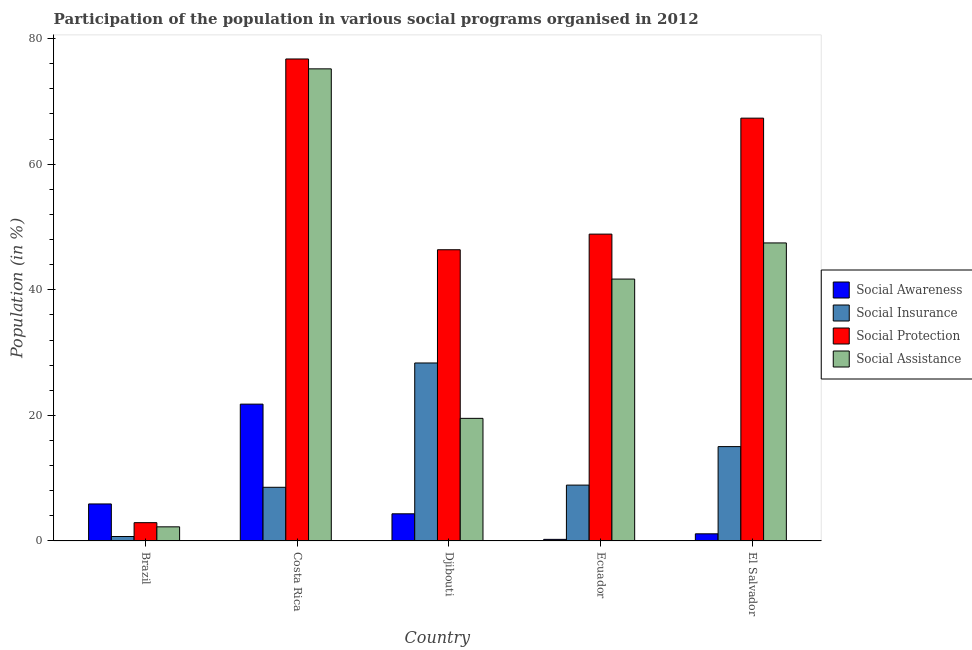Are the number of bars per tick equal to the number of legend labels?
Your answer should be compact. Yes. How many bars are there on the 4th tick from the left?
Give a very brief answer. 4. In how many cases, is the number of bars for a given country not equal to the number of legend labels?
Give a very brief answer. 0. What is the participation of population in social protection programs in Brazil?
Your answer should be very brief. 2.92. Across all countries, what is the maximum participation of population in social awareness programs?
Provide a succinct answer. 21.79. Across all countries, what is the minimum participation of population in social assistance programs?
Your answer should be compact. 2.25. In which country was the participation of population in social awareness programs minimum?
Provide a short and direct response. Ecuador. What is the total participation of population in social awareness programs in the graph?
Provide a short and direct response. 33.41. What is the difference between the participation of population in social assistance programs in Costa Rica and that in Djibouti?
Your response must be concise. 55.65. What is the difference between the participation of population in social assistance programs in Ecuador and the participation of population in social insurance programs in Brazil?
Give a very brief answer. 40.99. What is the average participation of population in social protection programs per country?
Keep it short and to the point. 48.45. What is the difference between the participation of population in social protection programs and participation of population in social insurance programs in Brazil?
Give a very brief answer. 2.2. In how many countries, is the participation of population in social awareness programs greater than 48 %?
Your answer should be compact. 0. What is the ratio of the participation of population in social assistance programs in Djibouti to that in El Salvador?
Ensure brevity in your answer.  0.41. Is the participation of population in social protection programs in Brazil less than that in El Salvador?
Keep it short and to the point. Yes. What is the difference between the highest and the second highest participation of population in social awareness programs?
Your answer should be very brief. 15.89. What is the difference between the highest and the lowest participation of population in social assistance programs?
Give a very brief answer. 72.93. Is the sum of the participation of population in social assistance programs in Djibouti and Ecuador greater than the maximum participation of population in social protection programs across all countries?
Ensure brevity in your answer.  No. Is it the case that in every country, the sum of the participation of population in social protection programs and participation of population in social assistance programs is greater than the sum of participation of population in social insurance programs and participation of population in social awareness programs?
Your answer should be compact. No. What does the 1st bar from the left in Costa Rica represents?
Keep it short and to the point. Social Awareness. What does the 2nd bar from the right in El Salvador represents?
Ensure brevity in your answer.  Social Protection. Is it the case that in every country, the sum of the participation of population in social awareness programs and participation of population in social insurance programs is greater than the participation of population in social protection programs?
Provide a succinct answer. No. How many bars are there?
Your answer should be compact. 20. What is the difference between two consecutive major ticks on the Y-axis?
Keep it short and to the point. 20. Are the values on the major ticks of Y-axis written in scientific E-notation?
Your response must be concise. No. Does the graph contain any zero values?
Ensure brevity in your answer.  No. Where does the legend appear in the graph?
Provide a short and direct response. Center right. How many legend labels are there?
Your answer should be very brief. 4. How are the legend labels stacked?
Make the answer very short. Vertical. What is the title of the graph?
Offer a terse response. Participation of the population in various social programs organised in 2012. What is the label or title of the Y-axis?
Your answer should be very brief. Population (in %). What is the Population (in %) of Social Awareness in Brazil?
Your answer should be compact. 5.9. What is the Population (in %) of Social Insurance in Brazil?
Your answer should be very brief. 0.71. What is the Population (in %) in Social Protection in Brazil?
Ensure brevity in your answer.  2.92. What is the Population (in %) in Social Assistance in Brazil?
Ensure brevity in your answer.  2.25. What is the Population (in %) of Social Awareness in Costa Rica?
Keep it short and to the point. 21.79. What is the Population (in %) of Social Insurance in Costa Rica?
Offer a very short reply. 8.55. What is the Population (in %) in Social Protection in Costa Rica?
Give a very brief answer. 76.75. What is the Population (in %) in Social Assistance in Costa Rica?
Give a very brief answer. 75.18. What is the Population (in %) in Social Awareness in Djibouti?
Your response must be concise. 4.33. What is the Population (in %) of Social Insurance in Djibouti?
Your answer should be compact. 28.34. What is the Population (in %) of Social Protection in Djibouti?
Offer a terse response. 46.38. What is the Population (in %) in Social Assistance in Djibouti?
Your answer should be very brief. 19.53. What is the Population (in %) of Social Awareness in Ecuador?
Your response must be concise. 0.26. What is the Population (in %) in Social Insurance in Ecuador?
Offer a very short reply. 8.9. What is the Population (in %) in Social Protection in Ecuador?
Your answer should be very brief. 48.86. What is the Population (in %) of Social Assistance in Ecuador?
Your answer should be very brief. 41.71. What is the Population (in %) in Social Awareness in El Salvador?
Keep it short and to the point. 1.14. What is the Population (in %) of Social Insurance in El Salvador?
Ensure brevity in your answer.  15.03. What is the Population (in %) of Social Protection in El Salvador?
Provide a succinct answer. 67.33. What is the Population (in %) of Social Assistance in El Salvador?
Your answer should be compact. 47.46. Across all countries, what is the maximum Population (in %) of Social Awareness?
Give a very brief answer. 21.79. Across all countries, what is the maximum Population (in %) in Social Insurance?
Offer a terse response. 28.34. Across all countries, what is the maximum Population (in %) of Social Protection?
Your answer should be compact. 76.75. Across all countries, what is the maximum Population (in %) of Social Assistance?
Provide a succinct answer. 75.18. Across all countries, what is the minimum Population (in %) in Social Awareness?
Keep it short and to the point. 0.26. Across all countries, what is the minimum Population (in %) in Social Insurance?
Your answer should be very brief. 0.71. Across all countries, what is the minimum Population (in %) of Social Protection?
Give a very brief answer. 2.92. Across all countries, what is the minimum Population (in %) of Social Assistance?
Make the answer very short. 2.25. What is the total Population (in %) of Social Awareness in the graph?
Give a very brief answer. 33.41. What is the total Population (in %) of Social Insurance in the graph?
Keep it short and to the point. 61.53. What is the total Population (in %) in Social Protection in the graph?
Give a very brief answer. 242.24. What is the total Population (in %) in Social Assistance in the graph?
Make the answer very short. 186.13. What is the difference between the Population (in %) in Social Awareness in Brazil and that in Costa Rica?
Ensure brevity in your answer.  -15.89. What is the difference between the Population (in %) of Social Insurance in Brazil and that in Costa Rica?
Your response must be concise. -7.84. What is the difference between the Population (in %) of Social Protection in Brazil and that in Costa Rica?
Give a very brief answer. -73.84. What is the difference between the Population (in %) in Social Assistance in Brazil and that in Costa Rica?
Give a very brief answer. -72.93. What is the difference between the Population (in %) of Social Awareness in Brazil and that in Djibouti?
Your answer should be compact. 1.57. What is the difference between the Population (in %) in Social Insurance in Brazil and that in Djibouti?
Offer a terse response. -27.63. What is the difference between the Population (in %) of Social Protection in Brazil and that in Djibouti?
Your answer should be compact. -43.46. What is the difference between the Population (in %) in Social Assistance in Brazil and that in Djibouti?
Offer a terse response. -17.28. What is the difference between the Population (in %) of Social Awareness in Brazil and that in Ecuador?
Keep it short and to the point. 5.64. What is the difference between the Population (in %) of Social Insurance in Brazil and that in Ecuador?
Your answer should be very brief. -8.19. What is the difference between the Population (in %) in Social Protection in Brazil and that in Ecuador?
Your answer should be very brief. -45.95. What is the difference between the Population (in %) in Social Assistance in Brazil and that in Ecuador?
Offer a terse response. -39.45. What is the difference between the Population (in %) in Social Awareness in Brazil and that in El Salvador?
Your answer should be very brief. 4.76. What is the difference between the Population (in %) of Social Insurance in Brazil and that in El Salvador?
Make the answer very short. -14.32. What is the difference between the Population (in %) in Social Protection in Brazil and that in El Salvador?
Offer a very short reply. -64.41. What is the difference between the Population (in %) in Social Assistance in Brazil and that in El Salvador?
Ensure brevity in your answer.  -45.21. What is the difference between the Population (in %) of Social Awareness in Costa Rica and that in Djibouti?
Keep it short and to the point. 17.46. What is the difference between the Population (in %) of Social Insurance in Costa Rica and that in Djibouti?
Keep it short and to the point. -19.79. What is the difference between the Population (in %) in Social Protection in Costa Rica and that in Djibouti?
Your response must be concise. 30.38. What is the difference between the Population (in %) in Social Assistance in Costa Rica and that in Djibouti?
Give a very brief answer. 55.65. What is the difference between the Population (in %) in Social Awareness in Costa Rica and that in Ecuador?
Ensure brevity in your answer.  21.53. What is the difference between the Population (in %) in Social Insurance in Costa Rica and that in Ecuador?
Give a very brief answer. -0.35. What is the difference between the Population (in %) of Social Protection in Costa Rica and that in Ecuador?
Give a very brief answer. 27.89. What is the difference between the Population (in %) of Social Assistance in Costa Rica and that in Ecuador?
Provide a short and direct response. 33.48. What is the difference between the Population (in %) of Social Awareness in Costa Rica and that in El Salvador?
Provide a succinct answer. 20.65. What is the difference between the Population (in %) in Social Insurance in Costa Rica and that in El Salvador?
Keep it short and to the point. -6.48. What is the difference between the Population (in %) in Social Protection in Costa Rica and that in El Salvador?
Provide a short and direct response. 9.42. What is the difference between the Population (in %) of Social Assistance in Costa Rica and that in El Salvador?
Your answer should be compact. 27.72. What is the difference between the Population (in %) of Social Awareness in Djibouti and that in Ecuador?
Make the answer very short. 4.07. What is the difference between the Population (in %) of Social Insurance in Djibouti and that in Ecuador?
Offer a terse response. 19.45. What is the difference between the Population (in %) of Social Protection in Djibouti and that in Ecuador?
Provide a succinct answer. -2.49. What is the difference between the Population (in %) in Social Assistance in Djibouti and that in Ecuador?
Your answer should be compact. -22.18. What is the difference between the Population (in %) in Social Awareness in Djibouti and that in El Salvador?
Make the answer very short. 3.19. What is the difference between the Population (in %) in Social Insurance in Djibouti and that in El Salvador?
Offer a terse response. 13.32. What is the difference between the Population (in %) of Social Protection in Djibouti and that in El Salvador?
Your response must be concise. -20.95. What is the difference between the Population (in %) in Social Assistance in Djibouti and that in El Salvador?
Keep it short and to the point. -27.93. What is the difference between the Population (in %) of Social Awareness in Ecuador and that in El Salvador?
Your answer should be compact. -0.88. What is the difference between the Population (in %) of Social Insurance in Ecuador and that in El Salvador?
Your answer should be very brief. -6.13. What is the difference between the Population (in %) of Social Protection in Ecuador and that in El Salvador?
Make the answer very short. -18.47. What is the difference between the Population (in %) of Social Assistance in Ecuador and that in El Salvador?
Provide a short and direct response. -5.76. What is the difference between the Population (in %) in Social Awareness in Brazil and the Population (in %) in Social Insurance in Costa Rica?
Your answer should be very brief. -2.65. What is the difference between the Population (in %) of Social Awareness in Brazil and the Population (in %) of Social Protection in Costa Rica?
Your response must be concise. -70.86. What is the difference between the Population (in %) of Social Awareness in Brazil and the Population (in %) of Social Assistance in Costa Rica?
Your answer should be very brief. -69.29. What is the difference between the Population (in %) in Social Insurance in Brazil and the Population (in %) in Social Protection in Costa Rica?
Give a very brief answer. -76.04. What is the difference between the Population (in %) in Social Insurance in Brazil and the Population (in %) in Social Assistance in Costa Rica?
Provide a succinct answer. -74.47. What is the difference between the Population (in %) of Social Protection in Brazil and the Population (in %) of Social Assistance in Costa Rica?
Ensure brevity in your answer.  -72.27. What is the difference between the Population (in %) in Social Awareness in Brazil and the Population (in %) in Social Insurance in Djibouti?
Ensure brevity in your answer.  -22.45. What is the difference between the Population (in %) in Social Awareness in Brazil and the Population (in %) in Social Protection in Djibouti?
Your answer should be compact. -40.48. What is the difference between the Population (in %) of Social Awareness in Brazil and the Population (in %) of Social Assistance in Djibouti?
Provide a succinct answer. -13.63. What is the difference between the Population (in %) of Social Insurance in Brazil and the Population (in %) of Social Protection in Djibouti?
Provide a short and direct response. -45.66. What is the difference between the Population (in %) in Social Insurance in Brazil and the Population (in %) in Social Assistance in Djibouti?
Make the answer very short. -18.82. What is the difference between the Population (in %) of Social Protection in Brazil and the Population (in %) of Social Assistance in Djibouti?
Offer a very short reply. -16.61. What is the difference between the Population (in %) of Social Awareness in Brazil and the Population (in %) of Social Insurance in Ecuador?
Provide a short and direct response. -3. What is the difference between the Population (in %) in Social Awareness in Brazil and the Population (in %) in Social Protection in Ecuador?
Offer a terse response. -42.97. What is the difference between the Population (in %) of Social Awareness in Brazil and the Population (in %) of Social Assistance in Ecuador?
Your answer should be very brief. -35.81. What is the difference between the Population (in %) in Social Insurance in Brazil and the Population (in %) in Social Protection in Ecuador?
Give a very brief answer. -48.15. What is the difference between the Population (in %) in Social Insurance in Brazil and the Population (in %) in Social Assistance in Ecuador?
Offer a very short reply. -40.99. What is the difference between the Population (in %) in Social Protection in Brazil and the Population (in %) in Social Assistance in Ecuador?
Your response must be concise. -38.79. What is the difference between the Population (in %) in Social Awareness in Brazil and the Population (in %) in Social Insurance in El Salvador?
Make the answer very short. -9.13. What is the difference between the Population (in %) in Social Awareness in Brazil and the Population (in %) in Social Protection in El Salvador?
Provide a succinct answer. -61.43. What is the difference between the Population (in %) in Social Awareness in Brazil and the Population (in %) in Social Assistance in El Salvador?
Provide a short and direct response. -41.56. What is the difference between the Population (in %) of Social Insurance in Brazil and the Population (in %) of Social Protection in El Salvador?
Offer a terse response. -66.62. What is the difference between the Population (in %) of Social Insurance in Brazil and the Population (in %) of Social Assistance in El Salvador?
Keep it short and to the point. -46.75. What is the difference between the Population (in %) of Social Protection in Brazil and the Population (in %) of Social Assistance in El Salvador?
Ensure brevity in your answer.  -44.54. What is the difference between the Population (in %) of Social Awareness in Costa Rica and the Population (in %) of Social Insurance in Djibouti?
Offer a very short reply. -6.55. What is the difference between the Population (in %) of Social Awareness in Costa Rica and the Population (in %) of Social Protection in Djibouti?
Give a very brief answer. -24.59. What is the difference between the Population (in %) of Social Awareness in Costa Rica and the Population (in %) of Social Assistance in Djibouti?
Provide a short and direct response. 2.26. What is the difference between the Population (in %) of Social Insurance in Costa Rica and the Population (in %) of Social Protection in Djibouti?
Ensure brevity in your answer.  -37.83. What is the difference between the Population (in %) of Social Insurance in Costa Rica and the Population (in %) of Social Assistance in Djibouti?
Your answer should be compact. -10.98. What is the difference between the Population (in %) of Social Protection in Costa Rica and the Population (in %) of Social Assistance in Djibouti?
Offer a terse response. 57.23. What is the difference between the Population (in %) in Social Awareness in Costa Rica and the Population (in %) in Social Insurance in Ecuador?
Provide a succinct answer. 12.89. What is the difference between the Population (in %) in Social Awareness in Costa Rica and the Population (in %) in Social Protection in Ecuador?
Provide a short and direct response. -27.07. What is the difference between the Population (in %) of Social Awareness in Costa Rica and the Population (in %) of Social Assistance in Ecuador?
Your answer should be compact. -19.91. What is the difference between the Population (in %) of Social Insurance in Costa Rica and the Population (in %) of Social Protection in Ecuador?
Give a very brief answer. -40.31. What is the difference between the Population (in %) of Social Insurance in Costa Rica and the Population (in %) of Social Assistance in Ecuador?
Your response must be concise. -33.16. What is the difference between the Population (in %) of Social Protection in Costa Rica and the Population (in %) of Social Assistance in Ecuador?
Your answer should be very brief. 35.05. What is the difference between the Population (in %) in Social Awareness in Costa Rica and the Population (in %) in Social Insurance in El Salvador?
Provide a succinct answer. 6.76. What is the difference between the Population (in %) of Social Awareness in Costa Rica and the Population (in %) of Social Protection in El Salvador?
Offer a very short reply. -45.54. What is the difference between the Population (in %) of Social Awareness in Costa Rica and the Population (in %) of Social Assistance in El Salvador?
Provide a succinct answer. -25.67. What is the difference between the Population (in %) of Social Insurance in Costa Rica and the Population (in %) of Social Protection in El Salvador?
Your answer should be very brief. -58.78. What is the difference between the Population (in %) of Social Insurance in Costa Rica and the Population (in %) of Social Assistance in El Salvador?
Provide a short and direct response. -38.91. What is the difference between the Population (in %) in Social Protection in Costa Rica and the Population (in %) in Social Assistance in El Salvador?
Offer a very short reply. 29.29. What is the difference between the Population (in %) in Social Awareness in Djibouti and the Population (in %) in Social Insurance in Ecuador?
Make the answer very short. -4.57. What is the difference between the Population (in %) in Social Awareness in Djibouti and the Population (in %) in Social Protection in Ecuador?
Provide a succinct answer. -44.54. What is the difference between the Population (in %) in Social Awareness in Djibouti and the Population (in %) in Social Assistance in Ecuador?
Give a very brief answer. -37.38. What is the difference between the Population (in %) of Social Insurance in Djibouti and the Population (in %) of Social Protection in Ecuador?
Keep it short and to the point. -20.52. What is the difference between the Population (in %) of Social Insurance in Djibouti and the Population (in %) of Social Assistance in Ecuador?
Ensure brevity in your answer.  -13.36. What is the difference between the Population (in %) of Social Protection in Djibouti and the Population (in %) of Social Assistance in Ecuador?
Make the answer very short. 4.67. What is the difference between the Population (in %) of Social Awareness in Djibouti and the Population (in %) of Social Insurance in El Salvador?
Provide a short and direct response. -10.7. What is the difference between the Population (in %) of Social Awareness in Djibouti and the Population (in %) of Social Protection in El Salvador?
Make the answer very short. -63. What is the difference between the Population (in %) of Social Awareness in Djibouti and the Population (in %) of Social Assistance in El Salvador?
Offer a terse response. -43.13. What is the difference between the Population (in %) of Social Insurance in Djibouti and the Population (in %) of Social Protection in El Salvador?
Provide a succinct answer. -38.99. What is the difference between the Population (in %) of Social Insurance in Djibouti and the Population (in %) of Social Assistance in El Salvador?
Offer a very short reply. -19.12. What is the difference between the Population (in %) in Social Protection in Djibouti and the Population (in %) in Social Assistance in El Salvador?
Provide a succinct answer. -1.08. What is the difference between the Population (in %) in Social Awareness in Ecuador and the Population (in %) in Social Insurance in El Salvador?
Provide a succinct answer. -14.77. What is the difference between the Population (in %) of Social Awareness in Ecuador and the Population (in %) of Social Protection in El Salvador?
Offer a terse response. -67.07. What is the difference between the Population (in %) in Social Awareness in Ecuador and the Population (in %) in Social Assistance in El Salvador?
Provide a succinct answer. -47.2. What is the difference between the Population (in %) of Social Insurance in Ecuador and the Population (in %) of Social Protection in El Salvador?
Your answer should be compact. -58.43. What is the difference between the Population (in %) in Social Insurance in Ecuador and the Population (in %) in Social Assistance in El Salvador?
Your answer should be very brief. -38.56. What is the difference between the Population (in %) in Social Protection in Ecuador and the Population (in %) in Social Assistance in El Salvador?
Offer a terse response. 1.4. What is the average Population (in %) in Social Awareness per country?
Ensure brevity in your answer.  6.68. What is the average Population (in %) in Social Insurance per country?
Make the answer very short. 12.31. What is the average Population (in %) of Social Protection per country?
Keep it short and to the point. 48.45. What is the average Population (in %) in Social Assistance per country?
Your answer should be compact. 37.23. What is the difference between the Population (in %) of Social Awareness and Population (in %) of Social Insurance in Brazil?
Ensure brevity in your answer.  5.19. What is the difference between the Population (in %) of Social Awareness and Population (in %) of Social Protection in Brazil?
Provide a succinct answer. 2.98. What is the difference between the Population (in %) in Social Awareness and Population (in %) in Social Assistance in Brazil?
Offer a very short reply. 3.65. What is the difference between the Population (in %) of Social Insurance and Population (in %) of Social Protection in Brazil?
Give a very brief answer. -2.2. What is the difference between the Population (in %) of Social Insurance and Population (in %) of Social Assistance in Brazil?
Provide a short and direct response. -1.54. What is the difference between the Population (in %) of Social Protection and Population (in %) of Social Assistance in Brazil?
Provide a succinct answer. 0.67. What is the difference between the Population (in %) in Social Awareness and Population (in %) in Social Insurance in Costa Rica?
Your response must be concise. 13.24. What is the difference between the Population (in %) of Social Awareness and Population (in %) of Social Protection in Costa Rica?
Your answer should be compact. -54.96. What is the difference between the Population (in %) of Social Awareness and Population (in %) of Social Assistance in Costa Rica?
Provide a succinct answer. -53.39. What is the difference between the Population (in %) of Social Insurance and Population (in %) of Social Protection in Costa Rica?
Ensure brevity in your answer.  -68.2. What is the difference between the Population (in %) of Social Insurance and Population (in %) of Social Assistance in Costa Rica?
Give a very brief answer. -66.63. What is the difference between the Population (in %) of Social Protection and Population (in %) of Social Assistance in Costa Rica?
Offer a terse response. 1.57. What is the difference between the Population (in %) in Social Awareness and Population (in %) in Social Insurance in Djibouti?
Your answer should be very brief. -24.02. What is the difference between the Population (in %) of Social Awareness and Population (in %) of Social Protection in Djibouti?
Provide a succinct answer. -42.05. What is the difference between the Population (in %) of Social Awareness and Population (in %) of Social Assistance in Djibouti?
Make the answer very short. -15.2. What is the difference between the Population (in %) in Social Insurance and Population (in %) in Social Protection in Djibouti?
Your answer should be very brief. -18.03. What is the difference between the Population (in %) in Social Insurance and Population (in %) in Social Assistance in Djibouti?
Give a very brief answer. 8.82. What is the difference between the Population (in %) of Social Protection and Population (in %) of Social Assistance in Djibouti?
Offer a terse response. 26.85. What is the difference between the Population (in %) in Social Awareness and Population (in %) in Social Insurance in Ecuador?
Ensure brevity in your answer.  -8.64. What is the difference between the Population (in %) in Social Awareness and Population (in %) in Social Protection in Ecuador?
Keep it short and to the point. -48.61. What is the difference between the Population (in %) of Social Awareness and Population (in %) of Social Assistance in Ecuador?
Provide a short and direct response. -41.45. What is the difference between the Population (in %) of Social Insurance and Population (in %) of Social Protection in Ecuador?
Provide a short and direct response. -39.97. What is the difference between the Population (in %) of Social Insurance and Population (in %) of Social Assistance in Ecuador?
Provide a short and direct response. -32.81. What is the difference between the Population (in %) of Social Protection and Population (in %) of Social Assistance in Ecuador?
Offer a very short reply. 7.16. What is the difference between the Population (in %) in Social Awareness and Population (in %) in Social Insurance in El Salvador?
Your response must be concise. -13.89. What is the difference between the Population (in %) of Social Awareness and Population (in %) of Social Protection in El Salvador?
Provide a succinct answer. -66.19. What is the difference between the Population (in %) of Social Awareness and Population (in %) of Social Assistance in El Salvador?
Make the answer very short. -46.32. What is the difference between the Population (in %) in Social Insurance and Population (in %) in Social Protection in El Salvador?
Offer a terse response. -52.3. What is the difference between the Population (in %) in Social Insurance and Population (in %) in Social Assistance in El Salvador?
Keep it short and to the point. -32.43. What is the difference between the Population (in %) of Social Protection and Population (in %) of Social Assistance in El Salvador?
Ensure brevity in your answer.  19.87. What is the ratio of the Population (in %) of Social Awareness in Brazil to that in Costa Rica?
Provide a succinct answer. 0.27. What is the ratio of the Population (in %) of Social Insurance in Brazil to that in Costa Rica?
Offer a terse response. 0.08. What is the ratio of the Population (in %) of Social Protection in Brazil to that in Costa Rica?
Make the answer very short. 0.04. What is the ratio of the Population (in %) of Social Awareness in Brazil to that in Djibouti?
Provide a short and direct response. 1.36. What is the ratio of the Population (in %) of Social Insurance in Brazil to that in Djibouti?
Offer a terse response. 0.03. What is the ratio of the Population (in %) of Social Protection in Brazil to that in Djibouti?
Make the answer very short. 0.06. What is the ratio of the Population (in %) of Social Assistance in Brazil to that in Djibouti?
Provide a succinct answer. 0.12. What is the ratio of the Population (in %) of Social Awareness in Brazil to that in Ecuador?
Keep it short and to the point. 22.95. What is the ratio of the Population (in %) in Social Protection in Brazil to that in Ecuador?
Ensure brevity in your answer.  0.06. What is the ratio of the Population (in %) of Social Assistance in Brazil to that in Ecuador?
Provide a succinct answer. 0.05. What is the ratio of the Population (in %) in Social Awareness in Brazil to that in El Salvador?
Give a very brief answer. 5.17. What is the ratio of the Population (in %) in Social Insurance in Brazil to that in El Salvador?
Offer a very short reply. 0.05. What is the ratio of the Population (in %) in Social Protection in Brazil to that in El Salvador?
Your answer should be very brief. 0.04. What is the ratio of the Population (in %) of Social Assistance in Brazil to that in El Salvador?
Make the answer very short. 0.05. What is the ratio of the Population (in %) of Social Awareness in Costa Rica to that in Djibouti?
Your response must be concise. 5.04. What is the ratio of the Population (in %) of Social Insurance in Costa Rica to that in Djibouti?
Provide a succinct answer. 0.3. What is the ratio of the Population (in %) in Social Protection in Costa Rica to that in Djibouti?
Your answer should be very brief. 1.66. What is the ratio of the Population (in %) in Social Assistance in Costa Rica to that in Djibouti?
Your answer should be compact. 3.85. What is the ratio of the Population (in %) in Social Awareness in Costa Rica to that in Ecuador?
Your answer should be very brief. 84.82. What is the ratio of the Population (in %) of Social Insurance in Costa Rica to that in Ecuador?
Provide a short and direct response. 0.96. What is the ratio of the Population (in %) in Social Protection in Costa Rica to that in Ecuador?
Ensure brevity in your answer.  1.57. What is the ratio of the Population (in %) of Social Assistance in Costa Rica to that in Ecuador?
Your answer should be very brief. 1.8. What is the ratio of the Population (in %) in Social Awareness in Costa Rica to that in El Salvador?
Your answer should be compact. 19.11. What is the ratio of the Population (in %) in Social Insurance in Costa Rica to that in El Salvador?
Make the answer very short. 0.57. What is the ratio of the Population (in %) in Social Protection in Costa Rica to that in El Salvador?
Make the answer very short. 1.14. What is the ratio of the Population (in %) of Social Assistance in Costa Rica to that in El Salvador?
Your answer should be very brief. 1.58. What is the ratio of the Population (in %) in Social Awareness in Djibouti to that in Ecuador?
Offer a terse response. 16.84. What is the ratio of the Population (in %) in Social Insurance in Djibouti to that in Ecuador?
Offer a very short reply. 3.19. What is the ratio of the Population (in %) of Social Protection in Djibouti to that in Ecuador?
Your answer should be very brief. 0.95. What is the ratio of the Population (in %) of Social Assistance in Djibouti to that in Ecuador?
Provide a succinct answer. 0.47. What is the ratio of the Population (in %) in Social Awareness in Djibouti to that in El Salvador?
Keep it short and to the point. 3.79. What is the ratio of the Population (in %) of Social Insurance in Djibouti to that in El Salvador?
Provide a short and direct response. 1.89. What is the ratio of the Population (in %) of Social Protection in Djibouti to that in El Salvador?
Offer a very short reply. 0.69. What is the ratio of the Population (in %) in Social Assistance in Djibouti to that in El Salvador?
Keep it short and to the point. 0.41. What is the ratio of the Population (in %) of Social Awareness in Ecuador to that in El Salvador?
Provide a short and direct response. 0.23. What is the ratio of the Population (in %) of Social Insurance in Ecuador to that in El Salvador?
Your answer should be very brief. 0.59. What is the ratio of the Population (in %) in Social Protection in Ecuador to that in El Salvador?
Give a very brief answer. 0.73. What is the ratio of the Population (in %) of Social Assistance in Ecuador to that in El Salvador?
Offer a terse response. 0.88. What is the difference between the highest and the second highest Population (in %) in Social Awareness?
Keep it short and to the point. 15.89. What is the difference between the highest and the second highest Population (in %) in Social Insurance?
Keep it short and to the point. 13.32. What is the difference between the highest and the second highest Population (in %) in Social Protection?
Offer a very short reply. 9.42. What is the difference between the highest and the second highest Population (in %) in Social Assistance?
Make the answer very short. 27.72. What is the difference between the highest and the lowest Population (in %) in Social Awareness?
Your response must be concise. 21.53. What is the difference between the highest and the lowest Population (in %) in Social Insurance?
Ensure brevity in your answer.  27.63. What is the difference between the highest and the lowest Population (in %) in Social Protection?
Your answer should be compact. 73.84. What is the difference between the highest and the lowest Population (in %) in Social Assistance?
Give a very brief answer. 72.93. 